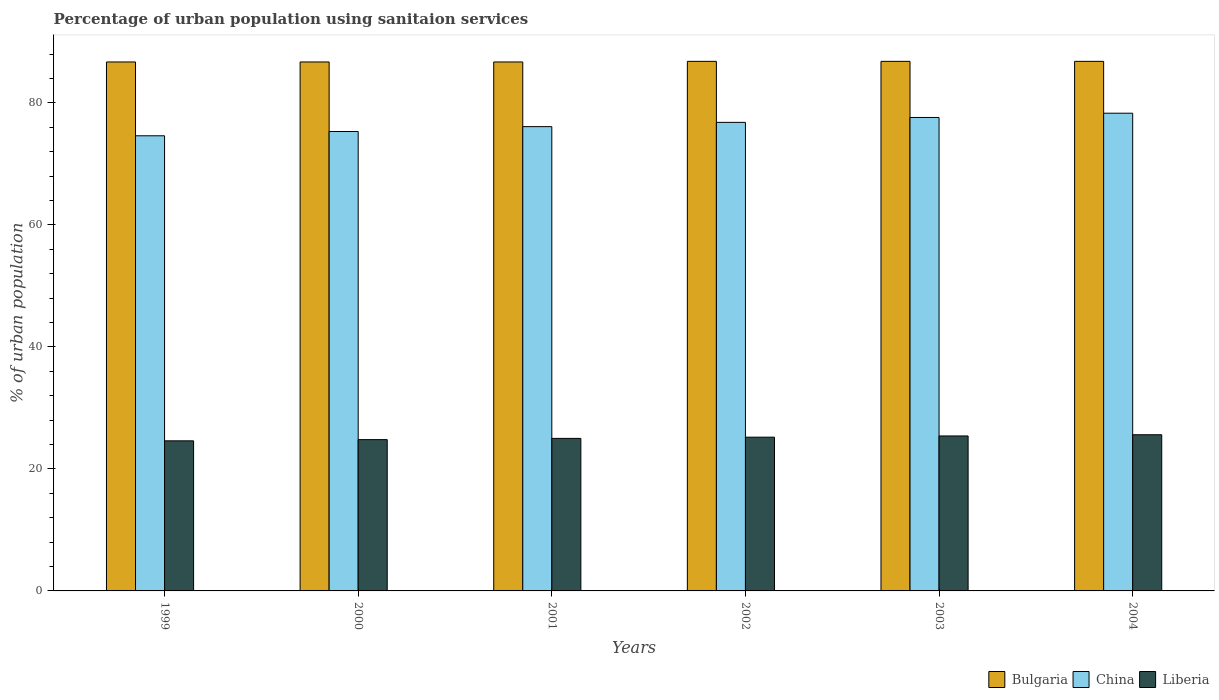Are the number of bars per tick equal to the number of legend labels?
Give a very brief answer. Yes. How many bars are there on the 5th tick from the left?
Your answer should be compact. 3. What is the label of the 1st group of bars from the left?
Provide a short and direct response. 1999. What is the percentage of urban population using sanitaion services in Bulgaria in 2002?
Keep it short and to the point. 86.8. Across all years, what is the maximum percentage of urban population using sanitaion services in Bulgaria?
Offer a terse response. 86.8. Across all years, what is the minimum percentage of urban population using sanitaion services in Liberia?
Make the answer very short. 24.6. In which year was the percentage of urban population using sanitaion services in Liberia minimum?
Your answer should be compact. 1999. What is the total percentage of urban population using sanitaion services in China in the graph?
Your answer should be compact. 458.7. What is the difference between the percentage of urban population using sanitaion services in Bulgaria in 1999 and that in 2003?
Offer a terse response. -0.1. What is the difference between the percentage of urban population using sanitaion services in China in 2003 and the percentage of urban population using sanitaion services in Bulgaria in 2004?
Keep it short and to the point. -9.2. What is the average percentage of urban population using sanitaion services in Liberia per year?
Provide a succinct answer. 25.1. In the year 2000, what is the difference between the percentage of urban population using sanitaion services in China and percentage of urban population using sanitaion services in Bulgaria?
Keep it short and to the point. -11.4. What is the ratio of the percentage of urban population using sanitaion services in China in 2000 to that in 2004?
Make the answer very short. 0.96. Is the percentage of urban population using sanitaion services in Bulgaria in 1999 less than that in 2004?
Keep it short and to the point. Yes. What is the difference between the highest and the second highest percentage of urban population using sanitaion services in Liberia?
Provide a succinct answer. 0.2. What is the difference between the highest and the lowest percentage of urban population using sanitaion services in Bulgaria?
Provide a short and direct response. 0.1. In how many years, is the percentage of urban population using sanitaion services in China greater than the average percentage of urban population using sanitaion services in China taken over all years?
Ensure brevity in your answer.  3. Is the sum of the percentage of urban population using sanitaion services in Liberia in 1999 and 2000 greater than the maximum percentage of urban population using sanitaion services in Bulgaria across all years?
Provide a short and direct response. No. What does the 2nd bar from the left in 2002 represents?
Your answer should be compact. China. What does the 2nd bar from the right in 2002 represents?
Provide a succinct answer. China. What is the difference between two consecutive major ticks on the Y-axis?
Ensure brevity in your answer.  20. Where does the legend appear in the graph?
Your answer should be very brief. Bottom right. How many legend labels are there?
Your response must be concise. 3. What is the title of the graph?
Make the answer very short. Percentage of urban population using sanitaion services. Does "Luxembourg" appear as one of the legend labels in the graph?
Provide a short and direct response. No. What is the label or title of the Y-axis?
Keep it short and to the point. % of urban population. What is the % of urban population of Bulgaria in 1999?
Offer a very short reply. 86.7. What is the % of urban population in China in 1999?
Make the answer very short. 74.6. What is the % of urban population in Liberia in 1999?
Provide a short and direct response. 24.6. What is the % of urban population of Bulgaria in 2000?
Your answer should be compact. 86.7. What is the % of urban population in China in 2000?
Make the answer very short. 75.3. What is the % of urban population of Liberia in 2000?
Your answer should be very brief. 24.8. What is the % of urban population in Bulgaria in 2001?
Provide a short and direct response. 86.7. What is the % of urban population of China in 2001?
Your answer should be very brief. 76.1. What is the % of urban population in Bulgaria in 2002?
Offer a terse response. 86.8. What is the % of urban population of China in 2002?
Provide a succinct answer. 76.8. What is the % of urban population of Liberia in 2002?
Make the answer very short. 25.2. What is the % of urban population of Bulgaria in 2003?
Give a very brief answer. 86.8. What is the % of urban population of China in 2003?
Your answer should be very brief. 77.6. What is the % of urban population of Liberia in 2003?
Give a very brief answer. 25.4. What is the % of urban population in Bulgaria in 2004?
Offer a terse response. 86.8. What is the % of urban population in China in 2004?
Your answer should be very brief. 78.3. What is the % of urban population in Liberia in 2004?
Your answer should be compact. 25.6. Across all years, what is the maximum % of urban population of Bulgaria?
Your response must be concise. 86.8. Across all years, what is the maximum % of urban population in China?
Provide a short and direct response. 78.3. Across all years, what is the maximum % of urban population in Liberia?
Provide a succinct answer. 25.6. Across all years, what is the minimum % of urban population in Bulgaria?
Your answer should be very brief. 86.7. Across all years, what is the minimum % of urban population in China?
Ensure brevity in your answer.  74.6. Across all years, what is the minimum % of urban population of Liberia?
Make the answer very short. 24.6. What is the total % of urban population of Bulgaria in the graph?
Ensure brevity in your answer.  520.5. What is the total % of urban population of China in the graph?
Your response must be concise. 458.7. What is the total % of urban population of Liberia in the graph?
Provide a succinct answer. 150.6. What is the difference between the % of urban population in Bulgaria in 1999 and that in 2000?
Offer a very short reply. 0. What is the difference between the % of urban population of Liberia in 1999 and that in 2000?
Keep it short and to the point. -0.2. What is the difference between the % of urban population in Bulgaria in 1999 and that in 2001?
Give a very brief answer. 0. What is the difference between the % of urban population in China in 1999 and that in 2001?
Your answer should be compact. -1.5. What is the difference between the % of urban population in China in 1999 and that in 2002?
Offer a terse response. -2.2. What is the difference between the % of urban population of Liberia in 1999 and that in 2002?
Your answer should be compact. -0.6. What is the difference between the % of urban population in Bulgaria in 1999 and that in 2003?
Provide a short and direct response. -0.1. What is the difference between the % of urban population of China in 1999 and that in 2003?
Keep it short and to the point. -3. What is the difference between the % of urban population in Bulgaria in 1999 and that in 2004?
Offer a terse response. -0.1. What is the difference between the % of urban population of Bulgaria in 2000 and that in 2001?
Provide a short and direct response. 0. What is the difference between the % of urban population in Liberia in 2000 and that in 2001?
Your answer should be very brief. -0.2. What is the difference between the % of urban population in Bulgaria in 2000 and that in 2002?
Your answer should be very brief. -0.1. What is the difference between the % of urban population in China in 2000 and that in 2002?
Ensure brevity in your answer.  -1.5. What is the difference between the % of urban population in China in 2000 and that in 2003?
Provide a succinct answer. -2.3. What is the difference between the % of urban population of Liberia in 2000 and that in 2003?
Keep it short and to the point. -0.6. What is the difference between the % of urban population of Bulgaria in 2000 and that in 2004?
Provide a short and direct response. -0.1. What is the difference between the % of urban population in Bulgaria in 2001 and that in 2003?
Give a very brief answer. -0.1. What is the difference between the % of urban population in China in 2001 and that in 2003?
Offer a very short reply. -1.5. What is the difference between the % of urban population in Liberia in 2001 and that in 2003?
Provide a succinct answer. -0.4. What is the difference between the % of urban population of China in 2001 and that in 2004?
Ensure brevity in your answer.  -2.2. What is the difference between the % of urban population of Bulgaria in 2002 and that in 2003?
Provide a succinct answer. 0. What is the difference between the % of urban population of China in 2002 and that in 2003?
Your response must be concise. -0.8. What is the difference between the % of urban population in Liberia in 2002 and that in 2003?
Keep it short and to the point. -0.2. What is the difference between the % of urban population in China in 2002 and that in 2004?
Provide a short and direct response. -1.5. What is the difference between the % of urban population in Bulgaria in 2003 and that in 2004?
Keep it short and to the point. 0. What is the difference between the % of urban population of Bulgaria in 1999 and the % of urban population of China in 2000?
Keep it short and to the point. 11.4. What is the difference between the % of urban population of Bulgaria in 1999 and the % of urban population of Liberia in 2000?
Give a very brief answer. 61.9. What is the difference between the % of urban population of China in 1999 and the % of urban population of Liberia in 2000?
Your answer should be very brief. 49.8. What is the difference between the % of urban population of Bulgaria in 1999 and the % of urban population of Liberia in 2001?
Provide a succinct answer. 61.7. What is the difference between the % of urban population of China in 1999 and the % of urban population of Liberia in 2001?
Your answer should be compact. 49.6. What is the difference between the % of urban population in Bulgaria in 1999 and the % of urban population in Liberia in 2002?
Your answer should be compact. 61.5. What is the difference between the % of urban population in China in 1999 and the % of urban population in Liberia in 2002?
Keep it short and to the point. 49.4. What is the difference between the % of urban population of Bulgaria in 1999 and the % of urban population of Liberia in 2003?
Make the answer very short. 61.3. What is the difference between the % of urban population of China in 1999 and the % of urban population of Liberia in 2003?
Your answer should be compact. 49.2. What is the difference between the % of urban population in Bulgaria in 1999 and the % of urban population in Liberia in 2004?
Provide a short and direct response. 61.1. What is the difference between the % of urban population in Bulgaria in 2000 and the % of urban population in Liberia in 2001?
Your response must be concise. 61.7. What is the difference between the % of urban population of China in 2000 and the % of urban population of Liberia in 2001?
Your response must be concise. 50.3. What is the difference between the % of urban population of Bulgaria in 2000 and the % of urban population of Liberia in 2002?
Your response must be concise. 61.5. What is the difference between the % of urban population in China in 2000 and the % of urban population in Liberia in 2002?
Make the answer very short. 50.1. What is the difference between the % of urban population of Bulgaria in 2000 and the % of urban population of Liberia in 2003?
Your answer should be compact. 61.3. What is the difference between the % of urban population in China in 2000 and the % of urban population in Liberia in 2003?
Offer a terse response. 49.9. What is the difference between the % of urban population of Bulgaria in 2000 and the % of urban population of China in 2004?
Your response must be concise. 8.4. What is the difference between the % of urban population in Bulgaria in 2000 and the % of urban population in Liberia in 2004?
Keep it short and to the point. 61.1. What is the difference between the % of urban population in China in 2000 and the % of urban population in Liberia in 2004?
Your response must be concise. 49.7. What is the difference between the % of urban population in Bulgaria in 2001 and the % of urban population in China in 2002?
Offer a very short reply. 9.9. What is the difference between the % of urban population in Bulgaria in 2001 and the % of urban population in Liberia in 2002?
Your answer should be very brief. 61.5. What is the difference between the % of urban population in China in 2001 and the % of urban population in Liberia in 2002?
Your response must be concise. 50.9. What is the difference between the % of urban population in Bulgaria in 2001 and the % of urban population in China in 2003?
Give a very brief answer. 9.1. What is the difference between the % of urban population in Bulgaria in 2001 and the % of urban population in Liberia in 2003?
Your answer should be very brief. 61.3. What is the difference between the % of urban population of China in 2001 and the % of urban population of Liberia in 2003?
Your response must be concise. 50.7. What is the difference between the % of urban population of Bulgaria in 2001 and the % of urban population of Liberia in 2004?
Ensure brevity in your answer.  61.1. What is the difference between the % of urban population in China in 2001 and the % of urban population in Liberia in 2004?
Offer a terse response. 50.5. What is the difference between the % of urban population of Bulgaria in 2002 and the % of urban population of Liberia in 2003?
Your response must be concise. 61.4. What is the difference between the % of urban population of China in 2002 and the % of urban population of Liberia in 2003?
Your answer should be very brief. 51.4. What is the difference between the % of urban population in Bulgaria in 2002 and the % of urban population in Liberia in 2004?
Keep it short and to the point. 61.2. What is the difference between the % of urban population in China in 2002 and the % of urban population in Liberia in 2004?
Provide a short and direct response. 51.2. What is the difference between the % of urban population in Bulgaria in 2003 and the % of urban population in Liberia in 2004?
Ensure brevity in your answer.  61.2. What is the difference between the % of urban population of China in 2003 and the % of urban population of Liberia in 2004?
Offer a very short reply. 52. What is the average % of urban population of Bulgaria per year?
Keep it short and to the point. 86.75. What is the average % of urban population in China per year?
Offer a very short reply. 76.45. What is the average % of urban population in Liberia per year?
Provide a succinct answer. 25.1. In the year 1999, what is the difference between the % of urban population of Bulgaria and % of urban population of China?
Provide a succinct answer. 12.1. In the year 1999, what is the difference between the % of urban population in Bulgaria and % of urban population in Liberia?
Keep it short and to the point. 62.1. In the year 1999, what is the difference between the % of urban population of China and % of urban population of Liberia?
Provide a succinct answer. 50. In the year 2000, what is the difference between the % of urban population of Bulgaria and % of urban population of Liberia?
Give a very brief answer. 61.9. In the year 2000, what is the difference between the % of urban population of China and % of urban population of Liberia?
Ensure brevity in your answer.  50.5. In the year 2001, what is the difference between the % of urban population in Bulgaria and % of urban population in China?
Your response must be concise. 10.6. In the year 2001, what is the difference between the % of urban population in Bulgaria and % of urban population in Liberia?
Provide a succinct answer. 61.7. In the year 2001, what is the difference between the % of urban population in China and % of urban population in Liberia?
Provide a succinct answer. 51.1. In the year 2002, what is the difference between the % of urban population of Bulgaria and % of urban population of China?
Make the answer very short. 10. In the year 2002, what is the difference between the % of urban population of Bulgaria and % of urban population of Liberia?
Your response must be concise. 61.6. In the year 2002, what is the difference between the % of urban population of China and % of urban population of Liberia?
Provide a short and direct response. 51.6. In the year 2003, what is the difference between the % of urban population of Bulgaria and % of urban population of Liberia?
Your answer should be very brief. 61.4. In the year 2003, what is the difference between the % of urban population in China and % of urban population in Liberia?
Provide a succinct answer. 52.2. In the year 2004, what is the difference between the % of urban population of Bulgaria and % of urban population of Liberia?
Offer a terse response. 61.2. In the year 2004, what is the difference between the % of urban population in China and % of urban population in Liberia?
Give a very brief answer. 52.7. What is the ratio of the % of urban population in China in 1999 to that in 2000?
Keep it short and to the point. 0.99. What is the ratio of the % of urban population in Liberia in 1999 to that in 2000?
Ensure brevity in your answer.  0.99. What is the ratio of the % of urban population of China in 1999 to that in 2001?
Give a very brief answer. 0.98. What is the ratio of the % of urban population of Liberia in 1999 to that in 2001?
Keep it short and to the point. 0.98. What is the ratio of the % of urban population of Bulgaria in 1999 to that in 2002?
Offer a very short reply. 1. What is the ratio of the % of urban population of China in 1999 to that in 2002?
Make the answer very short. 0.97. What is the ratio of the % of urban population in Liberia in 1999 to that in 2002?
Offer a terse response. 0.98. What is the ratio of the % of urban population of Bulgaria in 1999 to that in 2003?
Offer a terse response. 1. What is the ratio of the % of urban population of China in 1999 to that in 2003?
Ensure brevity in your answer.  0.96. What is the ratio of the % of urban population of Liberia in 1999 to that in 2003?
Your answer should be very brief. 0.97. What is the ratio of the % of urban population of Bulgaria in 1999 to that in 2004?
Provide a succinct answer. 1. What is the ratio of the % of urban population in China in 1999 to that in 2004?
Make the answer very short. 0.95. What is the ratio of the % of urban population in Liberia in 1999 to that in 2004?
Offer a terse response. 0.96. What is the ratio of the % of urban population in China in 2000 to that in 2001?
Your answer should be compact. 0.99. What is the ratio of the % of urban population in Liberia in 2000 to that in 2001?
Provide a short and direct response. 0.99. What is the ratio of the % of urban population of China in 2000 to that in 2002?
Give a very brief answer. 0.98. What is the ratio of the % of urban population in Liberia in 2000 to that in 2002?
Your answer should be very brief. 0.98. What is the ratio of the % of urban population of Bulgaria in 2000 to that in 2003?
Your response must be concise. 1. What is the ratio of the % of urban population in China in 2000 to that in 2003?
Make the answer very short. 0.97. What is the ratio of the % of urban population of Liberia in 2000 to that in 2003?
Provide a short and direct response. 0.98. What is the ratio of the % of urban population in China in 2000 to that in 2004?
Provide a succinct answer. 0.96. What is the ratio of the % of urban population of Liberia in 2000 to that in 2004?
Ensure brevity in your answer.  0.97. What is the ratio of the % of urban population in Bulgaria in 2001 to that in 2002?
Provide a short and direct response. 1. What is the ratio of the % of urban population in China in 2001 to that in 2002?
Keep it short and to the point. 0.99. What is the ratio of the % of urban population in China in 2001 to that in 2003?
Offer a terse response. 0.98. What is the ratio of the % of urban population of Liberia in 2001 to that in 2003?
Provide a succinct answer. 0.98. What is the ratio of the % of urban population of China in 2001 to that in 2004?
Keep it short and to the point. 0.97. What is the ratio of the % of urban population in Liberia in 2001 to that in 2004?
Offer a terse response. 0.98. What is the ratio of the % of urban population of China in 2002 to that in 2003?
Your answer should be very brief. 0.99. What is the ratio of the % of urban population of China in 2002 to that in 2004?
Provide a short and direct response. 0.98. What is the ratio of the % of urban population in Liberia in 2002 to that in 2004?
Provide a short and direct response. 0.98. What is the ratio of the % of urban population of Bulgaria in 2003 to that in 2004?
Offer a terse response. 1. What is the ratio of the % of urban population of China in 2003 to that in 2004?
Offer a terse response. 0.99. What is the ratio of the % of urban population of Liberia in 2003 to that in 2004?
Provide a short and direct response. 0.99. What is the difference between the highest and the second highest % of urban population in China?
Provide a short and direct response. 0.7. What is the difference between the highest and the lowest % of urban population of China?
Your answer should be very brief. 3.7. What is the difference between the highest and the lowest % of urban population of Liberia?
Offer a very short reply. 1. 